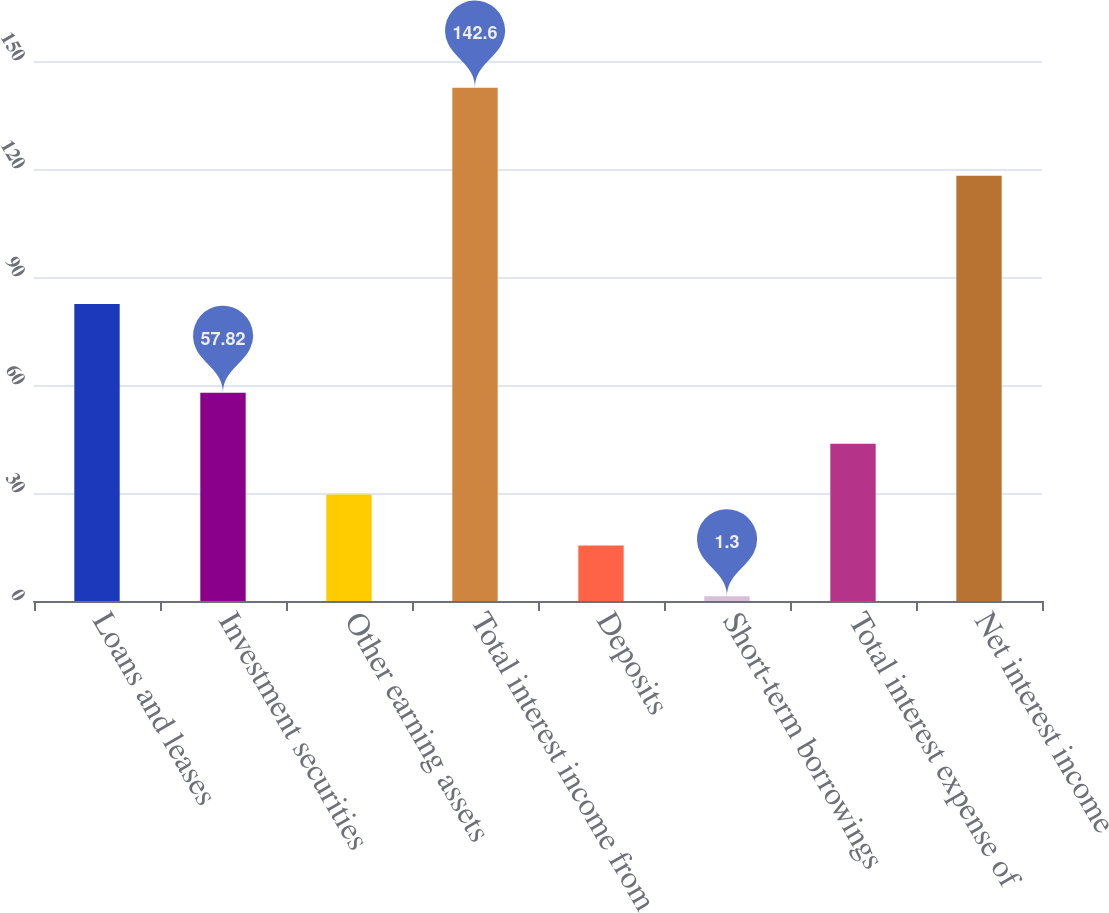Convert chart to OTSL. <chart><loc_0><loc_0><loc_500><loc_500><bar_chart><fcel>Loans and leases<fcel>Investment securities<fcel>Other earning assets<fcel>Total interest income from<fcel>Deposits<fcel>Short-term borrowings<fcel>Total interest expense of<fcel>Net interest income<nl><fcel>82.5<fcel>57.82<fcel>29.56<fcel>142.6<fcel>15.43<fcel>1.3<fcel>43.69<fcel>118.1<nl></chart> 